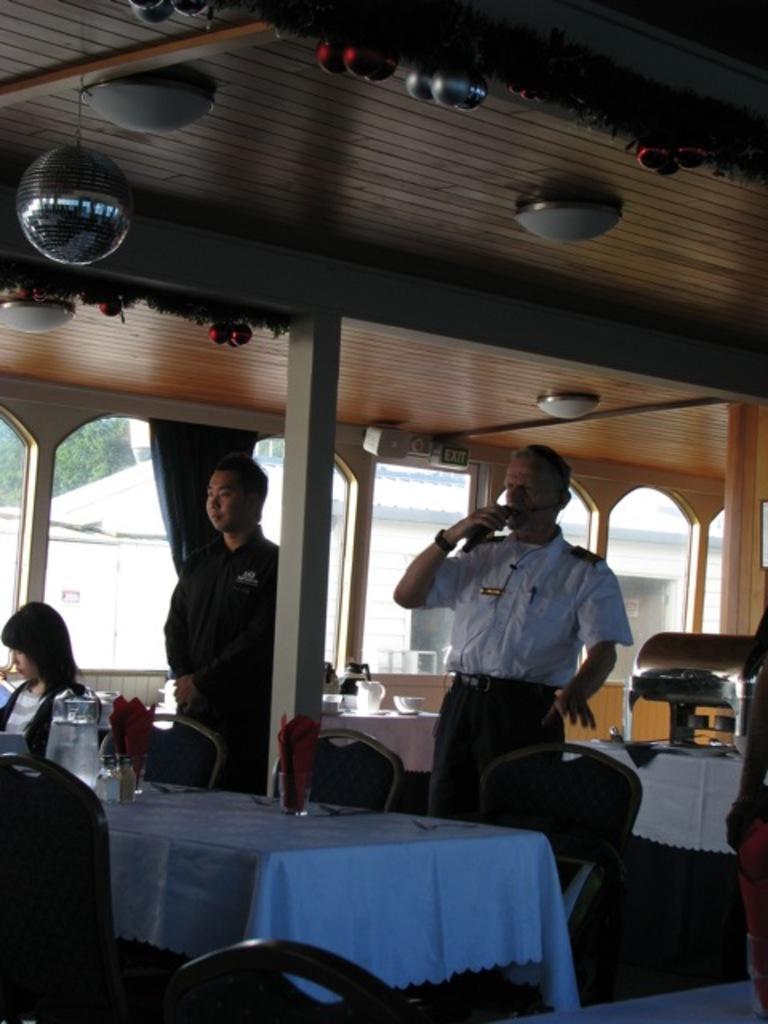Can you describe this image briefly? At the bottom of the image there are some tables and chairs, on the tables there are some glasses, spoons and jars and a person is sitting. In the middle of the image two persons are standing and he is holding a microphone. At the top of the image there is roof and lights. Behind them there is a glass window. Through the glass window we can see some trees. 